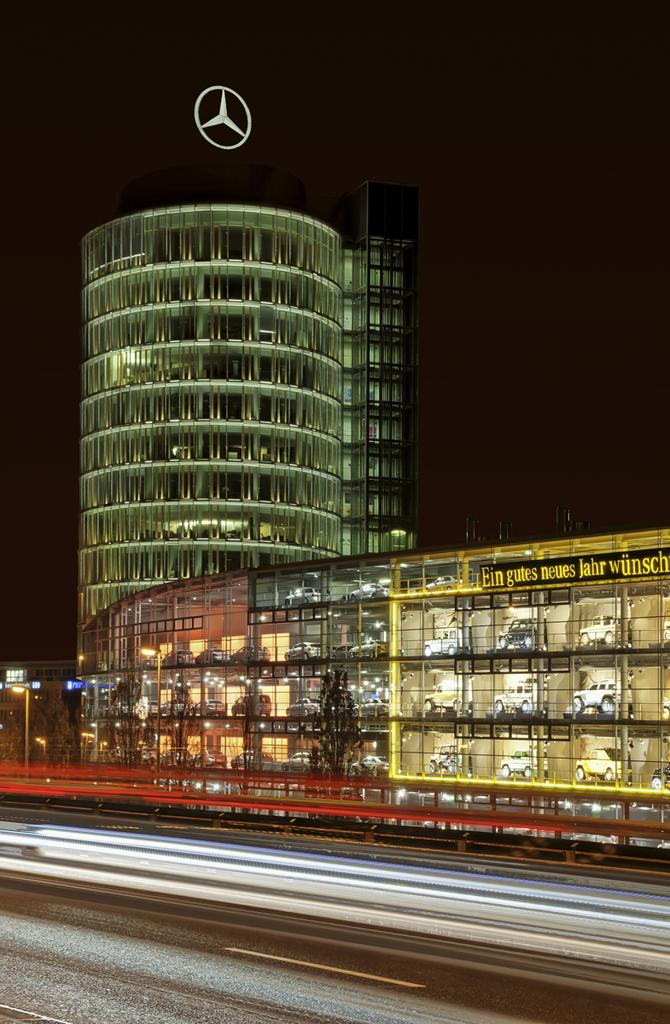What is the lighting condition in the image? The image was taken in the dark. What can be seen at the bottom of the image? There is a road visible at the bottom of the image. What is located in the background of the image? There is a building in the background of the image. How many chickens are sitting in the drawer in the image? There are no chickens or drawers present in the image. 